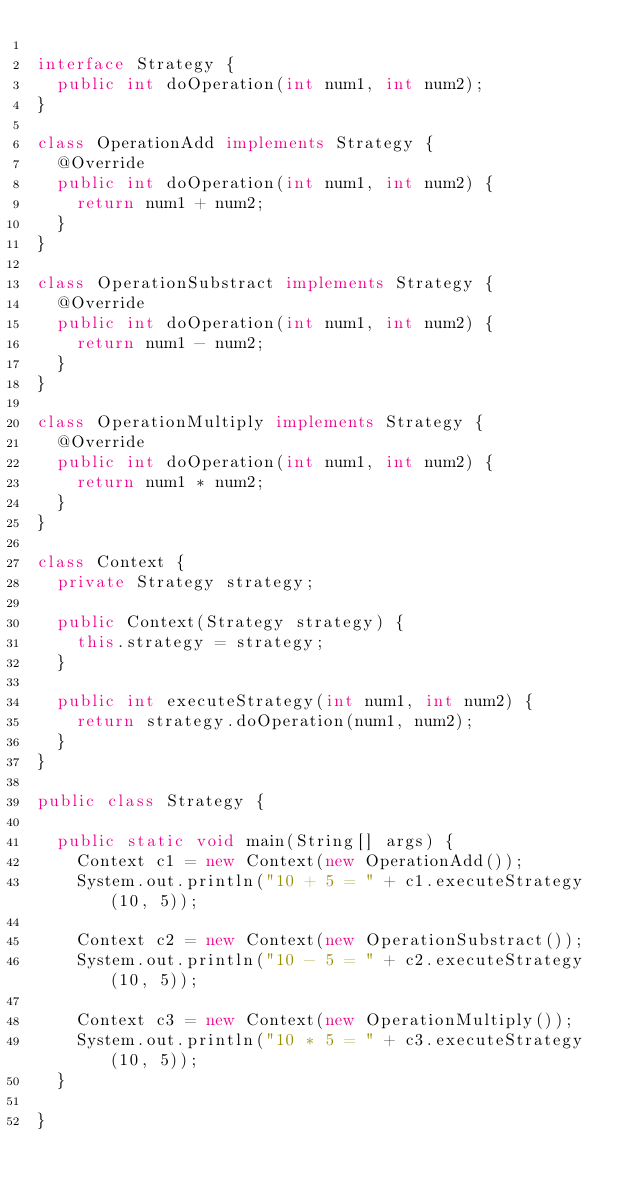Convert code to text. <code><loc_0><loc_0><loc_500><loc_500><_Java_>
interface Strategy {
	public int doOperation(int num1, int num2);
}

class OperationAdd implements Strategy {
	@Override
	public int doOperation(int num1, int num2) {
		return num1 + num2;
	}
}

class OperationSubstract implements Strategy {
	@Override
	public int doOperation(int num1, int num2) {
		return num1 - num2;
	}
}

class OperationMultiply implements Strategy {
	@Override
	public int doOperation(int num1, int num2) {
		return num1 * num2;
	}
}

class Context {
	private Strategy strategy;

	public Context(Strategy strategy) {
		this.strategy = strategy;
	}

	public int executeStrategy(int num1, int num2) {
		return strategy.doOperation(num1, num2);
	}
}

public class Strategy {

	public static void main(String[] args) {
		Context c1 = new Context(new OperationAdd());
		System.out.println("10 + 5 = " + c1.executeStrategy(10, 5));

		Context c2 = new Context(new OperationSubstract());
		System.out.println("10 - 5 = " + c2.executeStrategy(10, 5));

		Context c3 = new Context(new OperationMultiply());
		System.out.println("10 * 5 = " + c3.executeStrategy(10, 5));
	}

}
</code> 